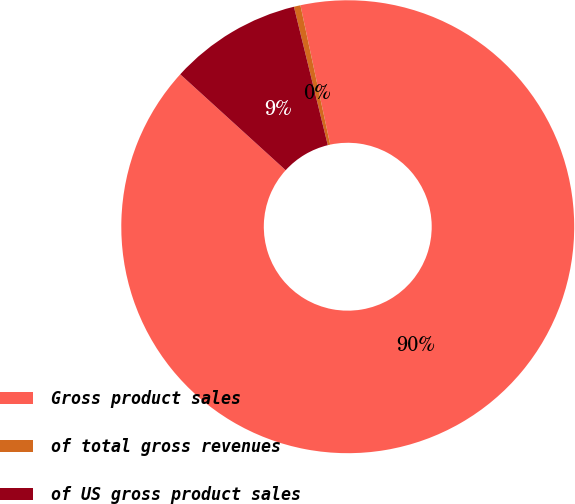Convert chart. <chart><loc_0><loc_0><loc_500><loc_500><pie_chart><fcel>Gross product sales<fcel>of total gross revenues<fcel>of US gross product sales<nl><fcel>90.1%<fcel>0.47%<fcel>9.43%<nl></chart> 